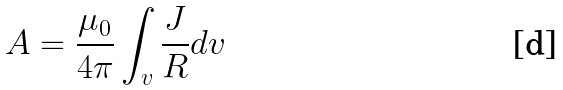<formula> <loc_0><loc_0><loc_500><loc_500>A = \frac { \mu _ { 0 } } { 4 \pi } \int _ { v } \frac { J } { R } d v</formula> 